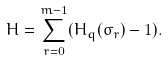<formula> <loc_0><loc_0><loc_500><loc_500>H = \sum _ { r = 0 } ^ { m - 1 } ( H _ { q } ( \sigma _ { r } ) - 1 ) .</formula> 